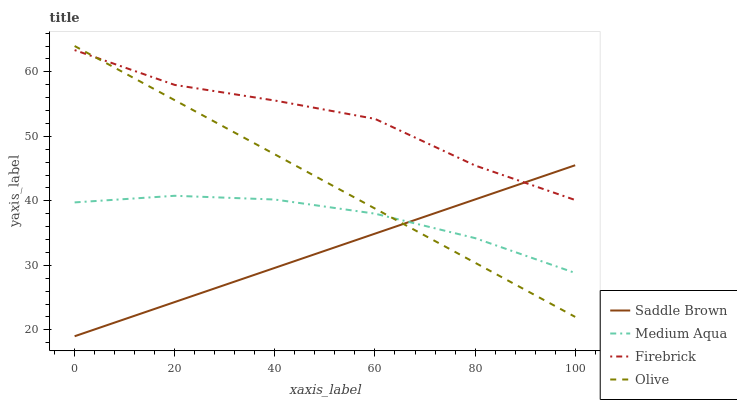Does Saddle Brown have the minimum area under the curve?
Answer yes or no. Yes. Does Firebrick have the maximum area under the curve?
Answer yes or no. Yes. Does Medium Aqua have the minimum area under the curve?
Answer yes or no. No. Does Medium Aqua have the maximum area under the curve?
Answer yes or no. No. Is Saddle Brown the smoothest?
Answer yes or no. Yes. Is Firebrick the roughest?
Answer yes or no. Yes. Is Medium Aqua the smoothest?
Answer yes or no. No. Is Medium Aqua the roughest?
Answer yes or no. No. Does Saddle Brown have the lowest value?
Answer yes or no. Yes. Does Medium Aqua have the lowest value?
Answer yes or no. No. Does Olive have the highest value?
Answer yes or no. Yes. Does Firebrick have the highest value?
Answer yes or no. No. Is Medium Aqua less than Firebrick?
Answer yes or no. Yes. Is Firebrick greater than Medium Aqua?
Answer yes or no. Yes. Does Saddle Brown intersect Medium Aqua?
Answer yes or no. Yes. Is Saddle Brown less than Medium Aqua?
Answer yes or no. No. Is Saddle Brown greater than Medium Aqua?
Answer yes or no. No. Does Medium Aqua intersect Firebrick?
Answer yes or no. No. 